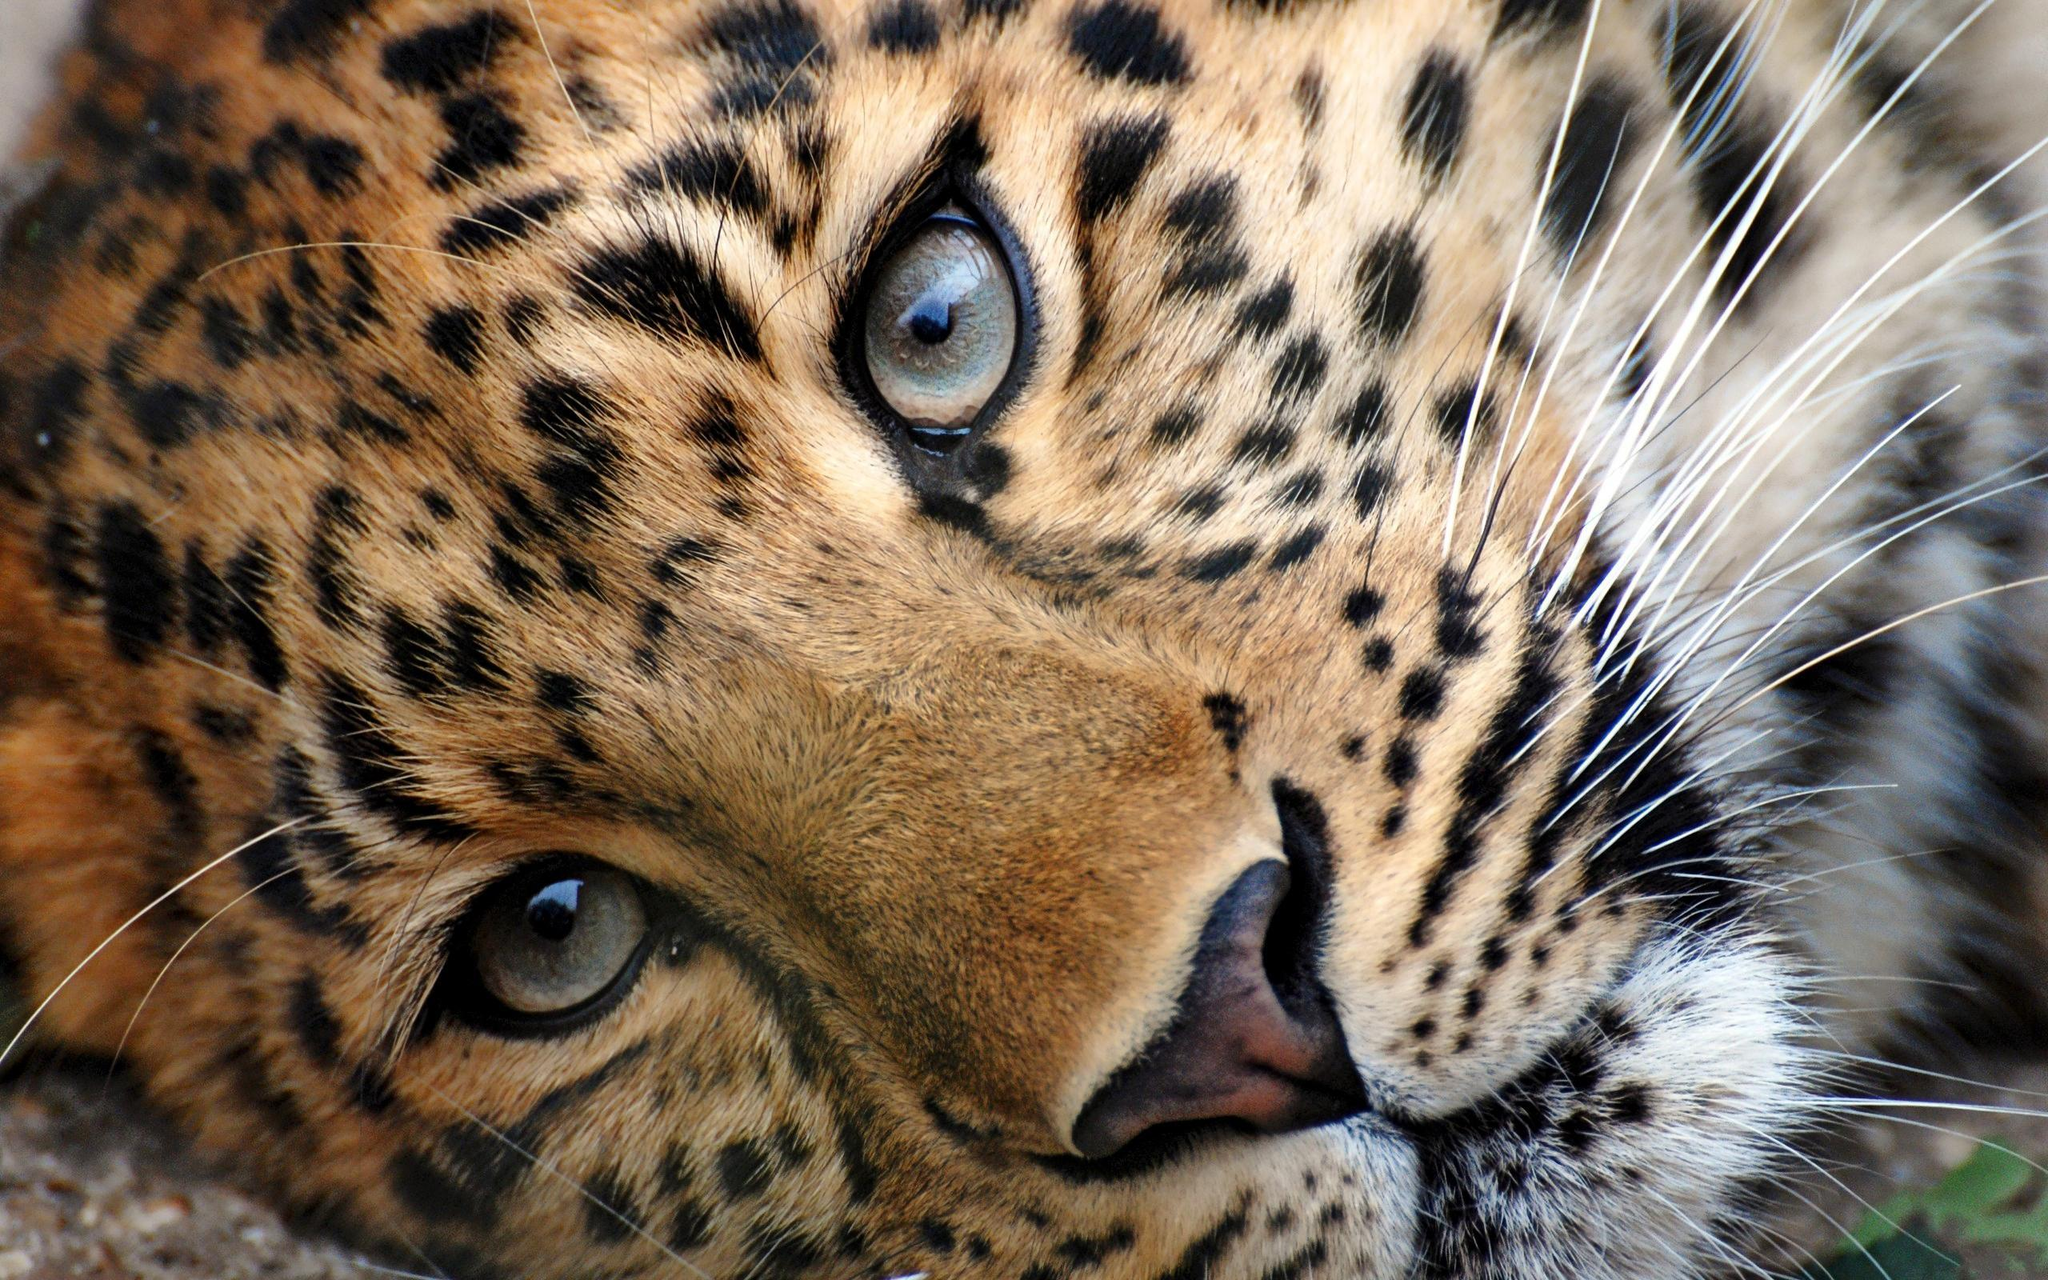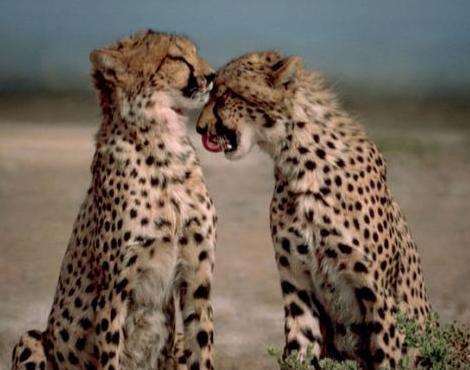The first image is the image on the left, the second image is the image on the right. Examine the images to the left and right. Is the description "There is at least 1 leopard kitten." accurate? Answer yes or no. Yes. 